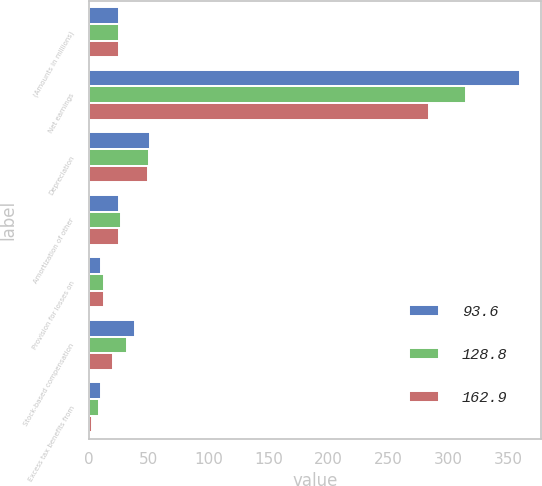Convert chart to OTSL. <chart><loc_0><loc_0><loc_500><loc_500><stacked_bar_chart><ecel><fcel>(Amounts in millions)<fcel>Net earnings<fcel>Depreciation<fcel>Amortization of other<fcel>Provision for losses on<fcel>Stock-based compensation<fcel>Excess tax benefits from<nl><fcel>93.6<fcel>25.3<fcel>359.7<fcel>51.2<fcel>25.5<fcel>10.4<fcel>38.5<fcel>9.8<nl><fcel>128.8<fcel>25.3<fcel>314.6<fcel>50.2<fcel>26.5<fcel>12.6<fcel>32.1<fcel>8.2<nl><fcel>162.9<fcel>25.3<fcel>283.8<fcel>49.3<fcel>25.3<fcel>12.9<fcel>20.3<fcel>2.8<nl></chart> 